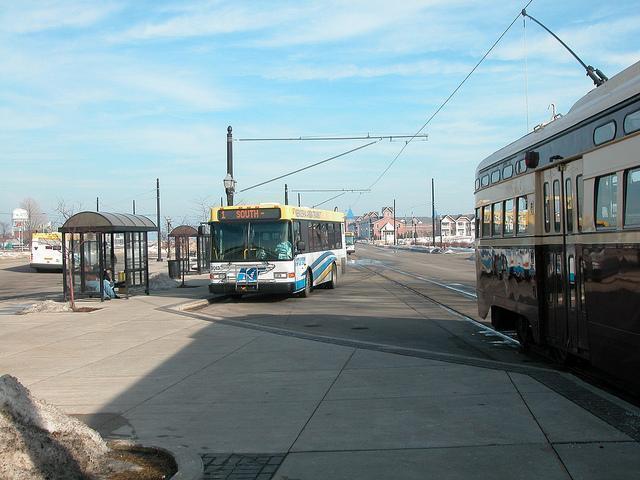What is the overhead wire for?
Indicate the correct response and explain using: 'Answer: answer
Rationale: rationale.'
Options: Power streetcars, guides streetcar, electric utility, phone lines. Answer: power streetcars.
Rationale: Thick wires extend across the street in a town. 